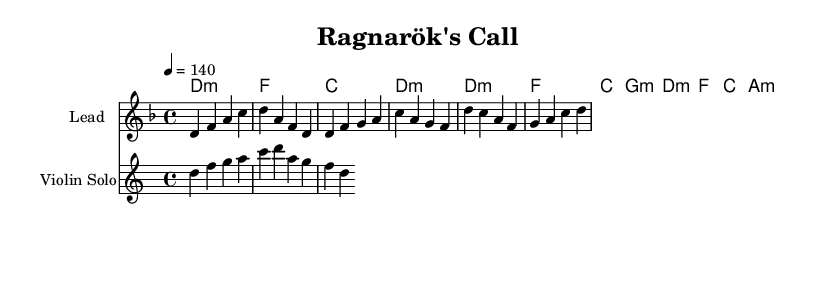What is the time signature of this music? The time signature is indicated at the beginning of the sheet music as 4/4, which means there are four beats per measure and the quarter note gets one beat.
Answer: 4/4 What is the key signature of this piece? The key signature is D minor, which contains one flat (B flat), and is indicated by the relevant notation at the beginning of the score.
Answer: D minor What is the tempo marking for the piece? The tempo marking can be found at the beginning and indicates the speed of the music. In this case, it is shown as a quarter note equals 140 beats per minute.
Answer: 140 How many measures are in the intro section? By looking at the measures that are labeled as the intro, which contains four measures, we can count them directly.
Answer: 4 What type of harmony is used in the chorus? The harmony for the chorus consists of minor chords, as indicated by the chord symbols written throughout the score, specifically using D minor, F major, C major, and A minor.
Answer: Minor What instrument plays the violin solo? The instrument specified in the score for the violin part is labeled as "Violin Solo" in the staff notation.
Answer: Violin What section follows the verse in this music? By analyzing the structure provided in the code, we see that the chorus immediately follows the verse after the initial intro.
Answer: Chorus 